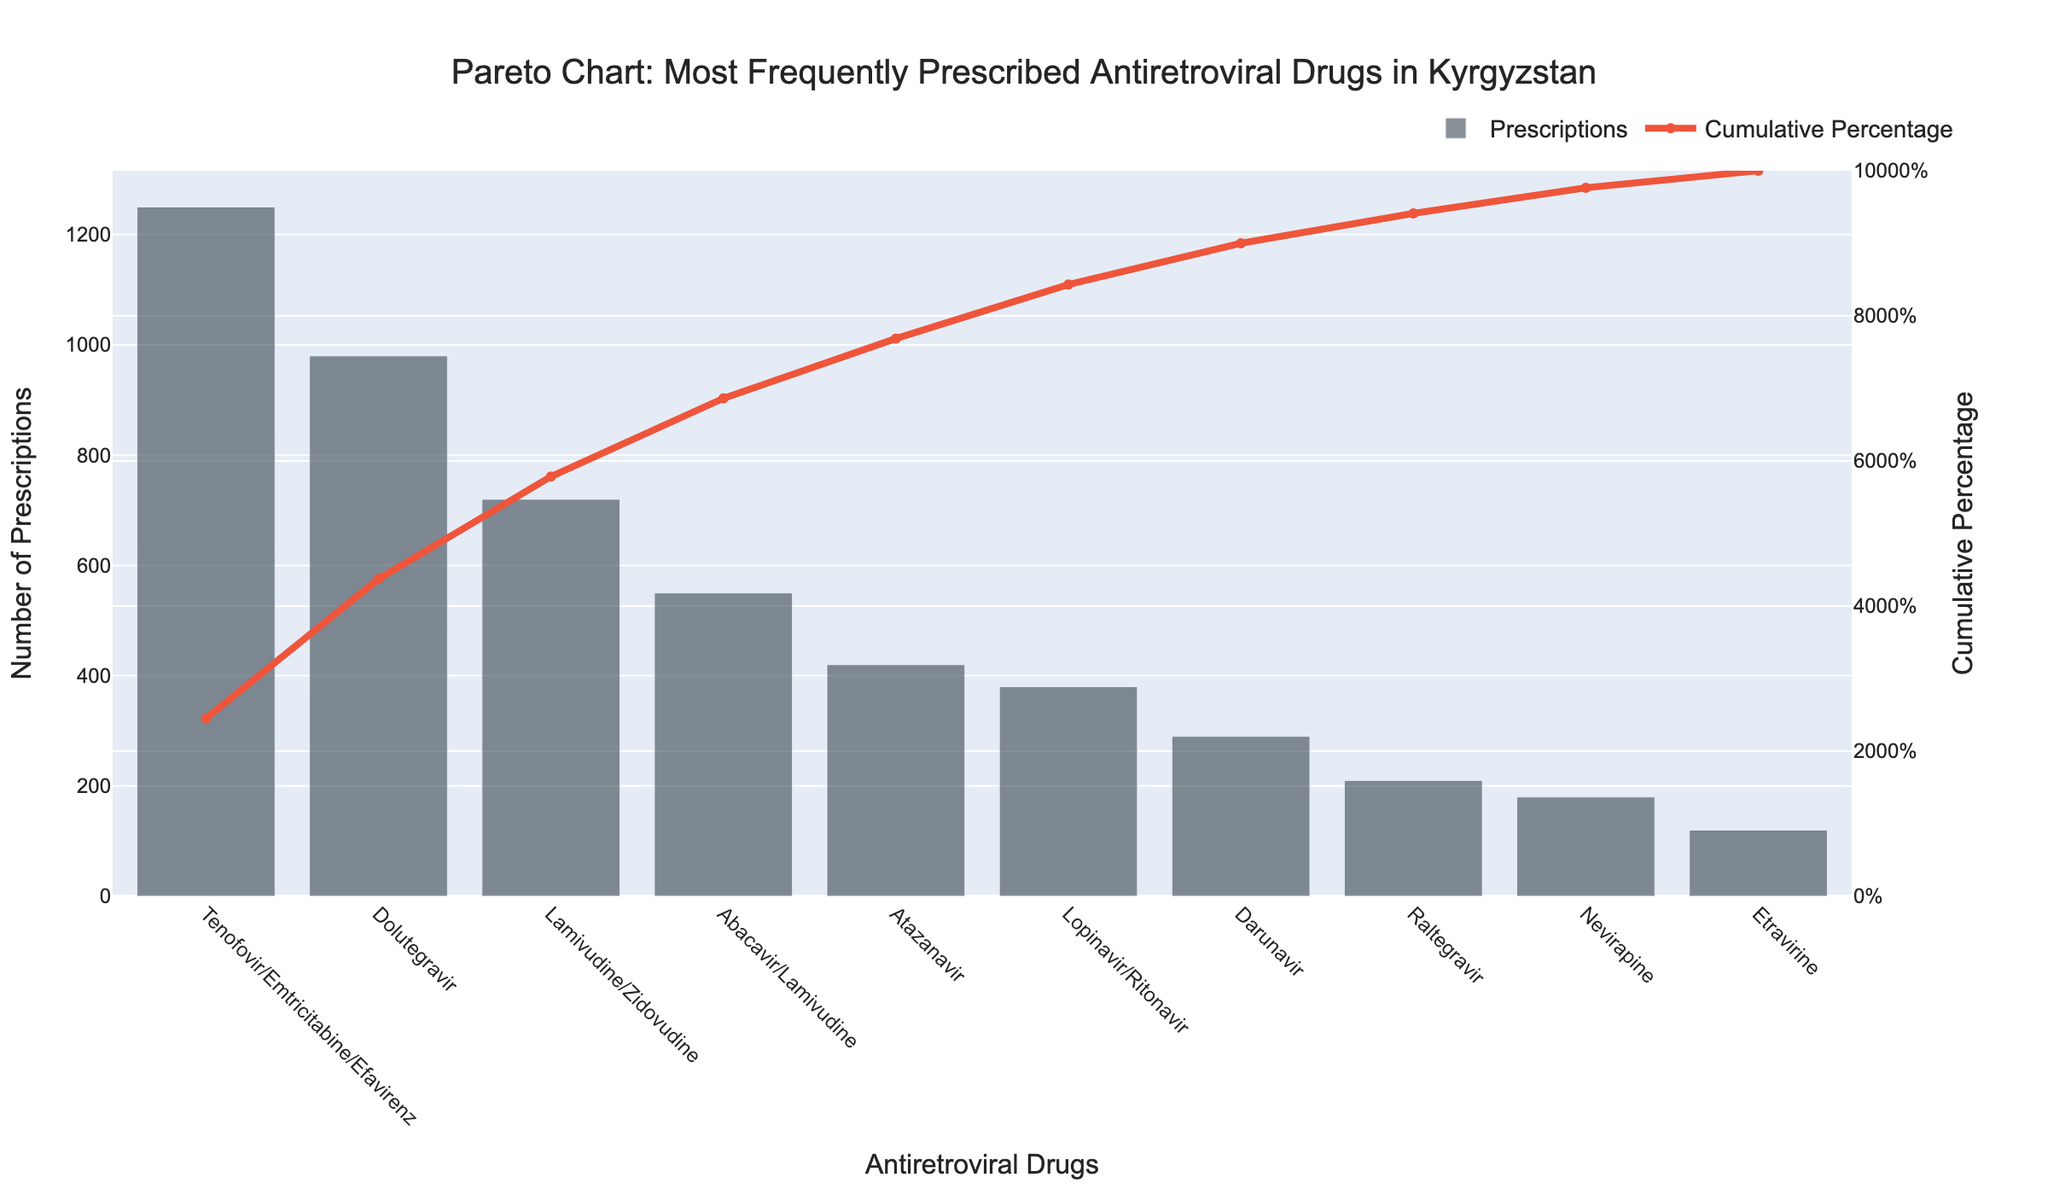What is the title of the Pareto chart? The title of the figure is usually written at the top of the chart. It summarizes the main subject of the visualization.
Answer: Pareto Chart: Most Frequently Prescribed Antiretroviral Drugs in Kyrgyzstan What does the y-axis on the left side represent? The left y-axis typically represents the primary quantity being measured in a bar chart, which in this case is the number of prescriptions.
Answer: Number of Prescriptions Which antiretroviral drug has the highest number of prescriptions? The drug with the highest bar corresponds to the maximum number of prescriptions.
Answer: Tenofovir/Emtricitabine/Efavirenz What is the cumulative percentage of the top three prescribed drugs? Locate the cumulative percentage values corresponding to the first, second, and third highest values and add them up.
Answer: 70% Which drug is responsible for reaching the 80% cumulative percentage threshold? Check the cumulative percentage line on the Pareto chart and identify the drug at or nearest to the 80% point.
Answer: Lamivudine/Zidovudine What’s the difference in the number of prescriptions between Tenofovir/Emtricitabine/Efavirenz and Dolutegravir? Look at the heights of the bars for the two drugs and subtract the shorter one from the taller one.
Answer: 270 How many drugs have fewer than 200 prescriptions? Count the number of bars that represent fewer than 200 prescriptions.
Answer: 3 Which antiretroviral drug has the fourth highest number of prescriptions? Identify the fourth tallest bar in the bar chart.
Answer: Abacavir/Lamivudine What is the percentage of prescriptions covered by the top two prescribed drugs? Add the cumulative percentages of the first and second drugs. These values are visible in the line plot corresponding to each bar.
Answer: 46.3% How many drugs account for approximately 90% of the total prescriptions? Review the cumulative percentage line and count the number of drugs up to the point where the cumulative percentage reaches or is closest to 90%.
Answer: 6 